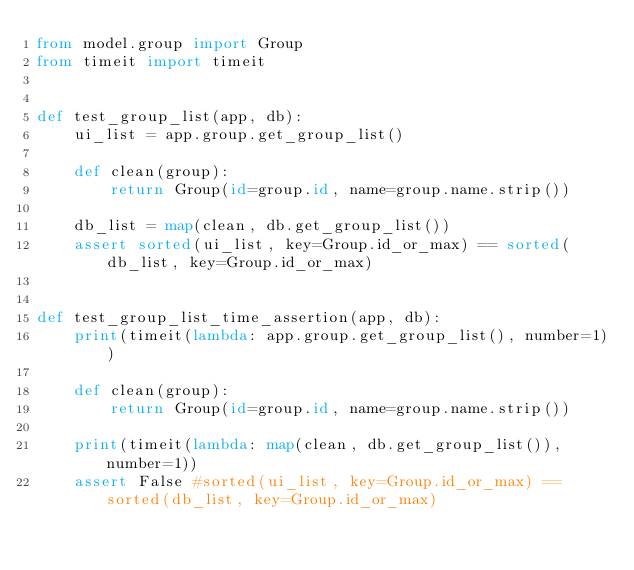<code> <loc_0><loc_0><loc_500><loc_500><_Python_>from model.group import Group
from timeit import timeit


def test_group_list(app, db):
    ui_list = app.group.get_group_list()

    def clean(group):
        return Group(id=group.id, name=group.name.strip())

    db_list = map(clean, db.get_group_list())
    assert sorted(ui_list, key=Group.id_or_max) == sorted(db_list, key=Group.id_or_max)


def test_group_list_time_assertion(app, db):
    print(timeit(lambda: app.group.get_group_list(), number=1))

    def clean(group):
        return Group(id=group.id, name=group.name.strip())

    print(timeit(lambda: map(clean, db.get_group_list()), number=1))
    assert False #sorted(ui_list, key=Group.id_or_max) == sorted(db_list, key=Group.id_or_max)</code> 